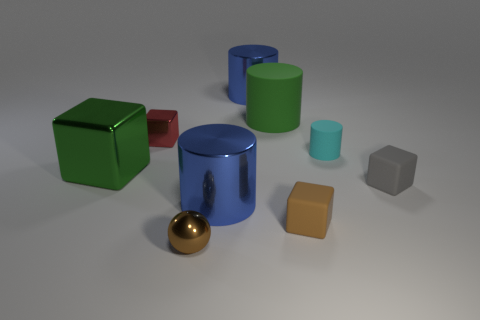There is a rubber block that is in front of the big blue cylinder that is in front of the green metallic cube; how big is it?
Make the answer very short. Small. How many big things are the same shape as the tiny red shiny thing?
Keep it short and to the point. 1. Do the tiny cylinder and the small sphere have the same color?
Your response must be concise. No. Is there any other thing that has the same shape as the green matte thing?
Make the answer very short. Yes. Are there any tiny objects that have the same color as the large rubber cylinder?
Your response must be concise. No. Are the tiny object on the left side of the small brown shiny object and the brown thing right of the green cylinder made of the same material?
Ensure brevity in your answer.  No. What is the color of the metal sphere?
Offer a terse response. Brown. What size is the cyan thing in front of the metallic cylinder that is behind the green thing to the right of the red metal cube?
Your answer should be very brief. Small. How many other objects are there of the same size as the cyan rubber cylinder?
Your answer should be compact. 4. How many large cylinders are the same material as the tiny brown cube?
Keep it short and to the point. 1. 